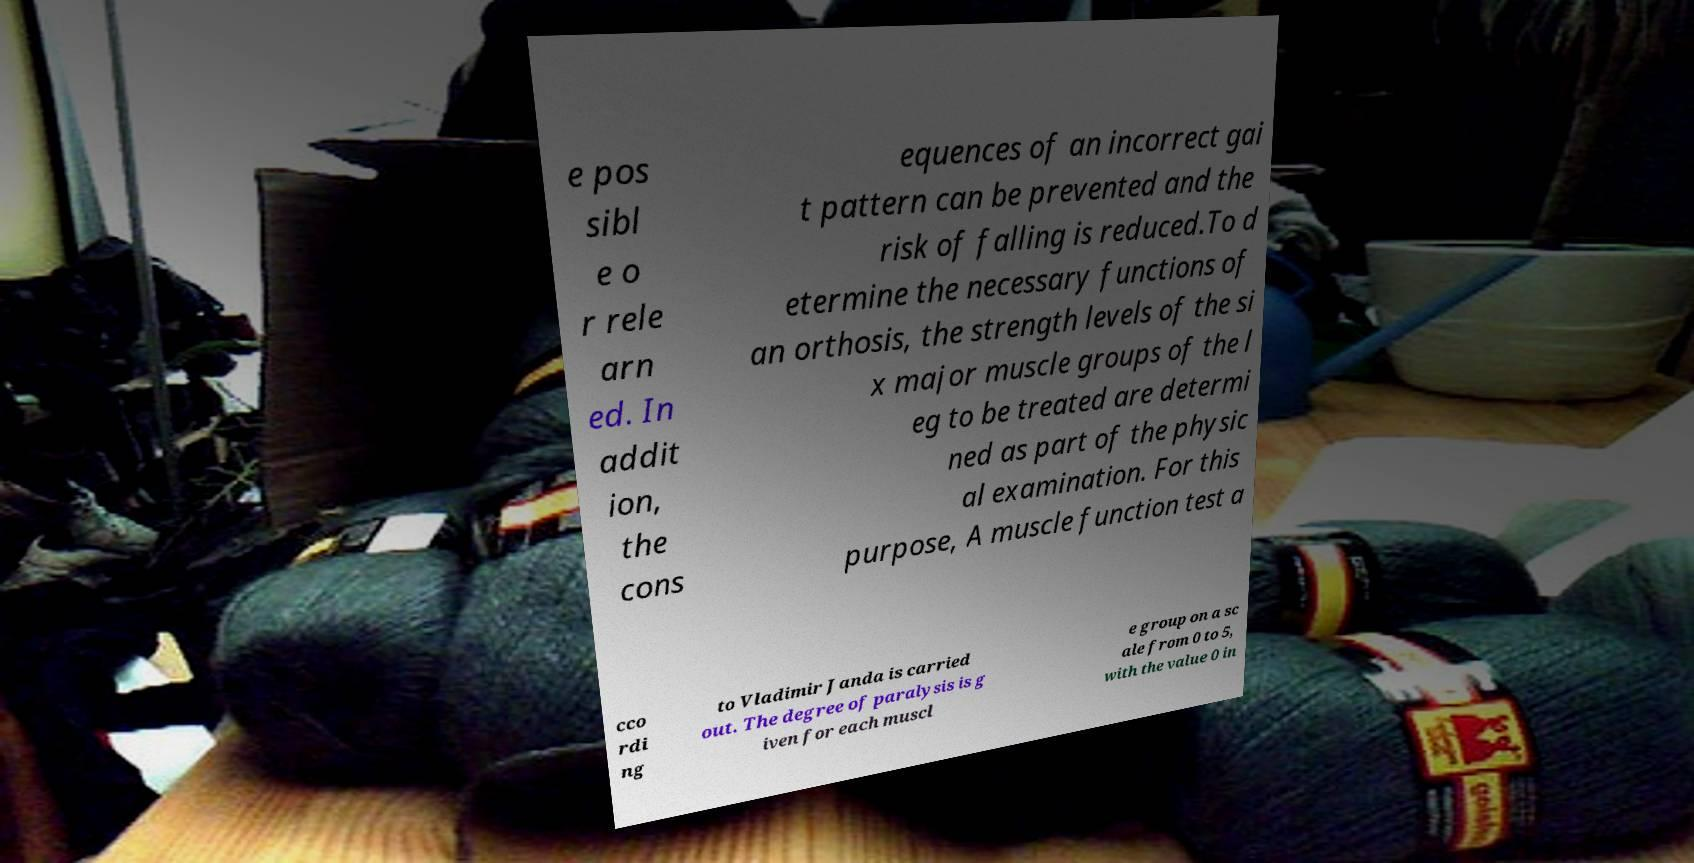Please read and relay the text visible in this image. What does it say? e pos sibl e o r rele arn ed. In addit ion, the cons equences of an incorrect gai t pattern can be prevented and the risk of falling is reduced.To d etermine the necessary functions of an orthosis, the strength levels of the si x major muscle groups of the l eg to be treated are determi ned as part of the physic al examination. For this purpose, A muscle function test a cco rdi ng to Vladimir Janda is carried out. The degree of paralysis is g iven for each muscl e group on a sc ale from 0 to 5, with the value 0 in 